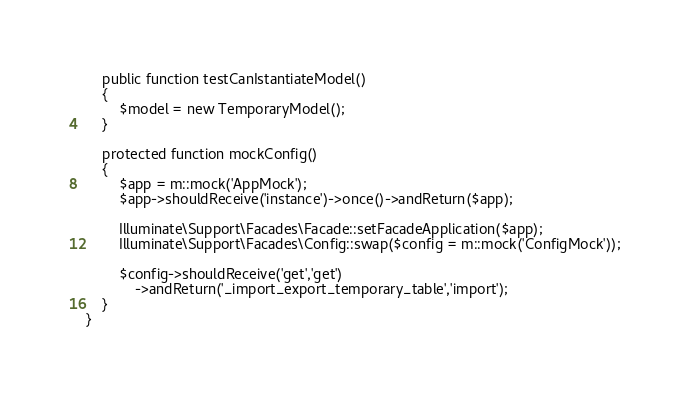Convert code to text. <code><loc_0><loc_0><loc_500><loc_500><_PHP_>
	public function testCanIstantiateModel()
	{
		$model = new TemporaryModel();
	}

	protected function mockConfig()
	{
		$app = m::mock('AppMock');
		$app->shouldReceive('instance')->once()->andReturn($app);

		Illuminate\Support\Facades\Facade::setFacadeApplication($app);
		Illuminate\Support\Facades\Config::swap($config = m::mock('ConfigMock'));

		$config->shouldReceive('get','get')
			->andReturn('_import_export_temporary_table','import');
	}
}</code> 